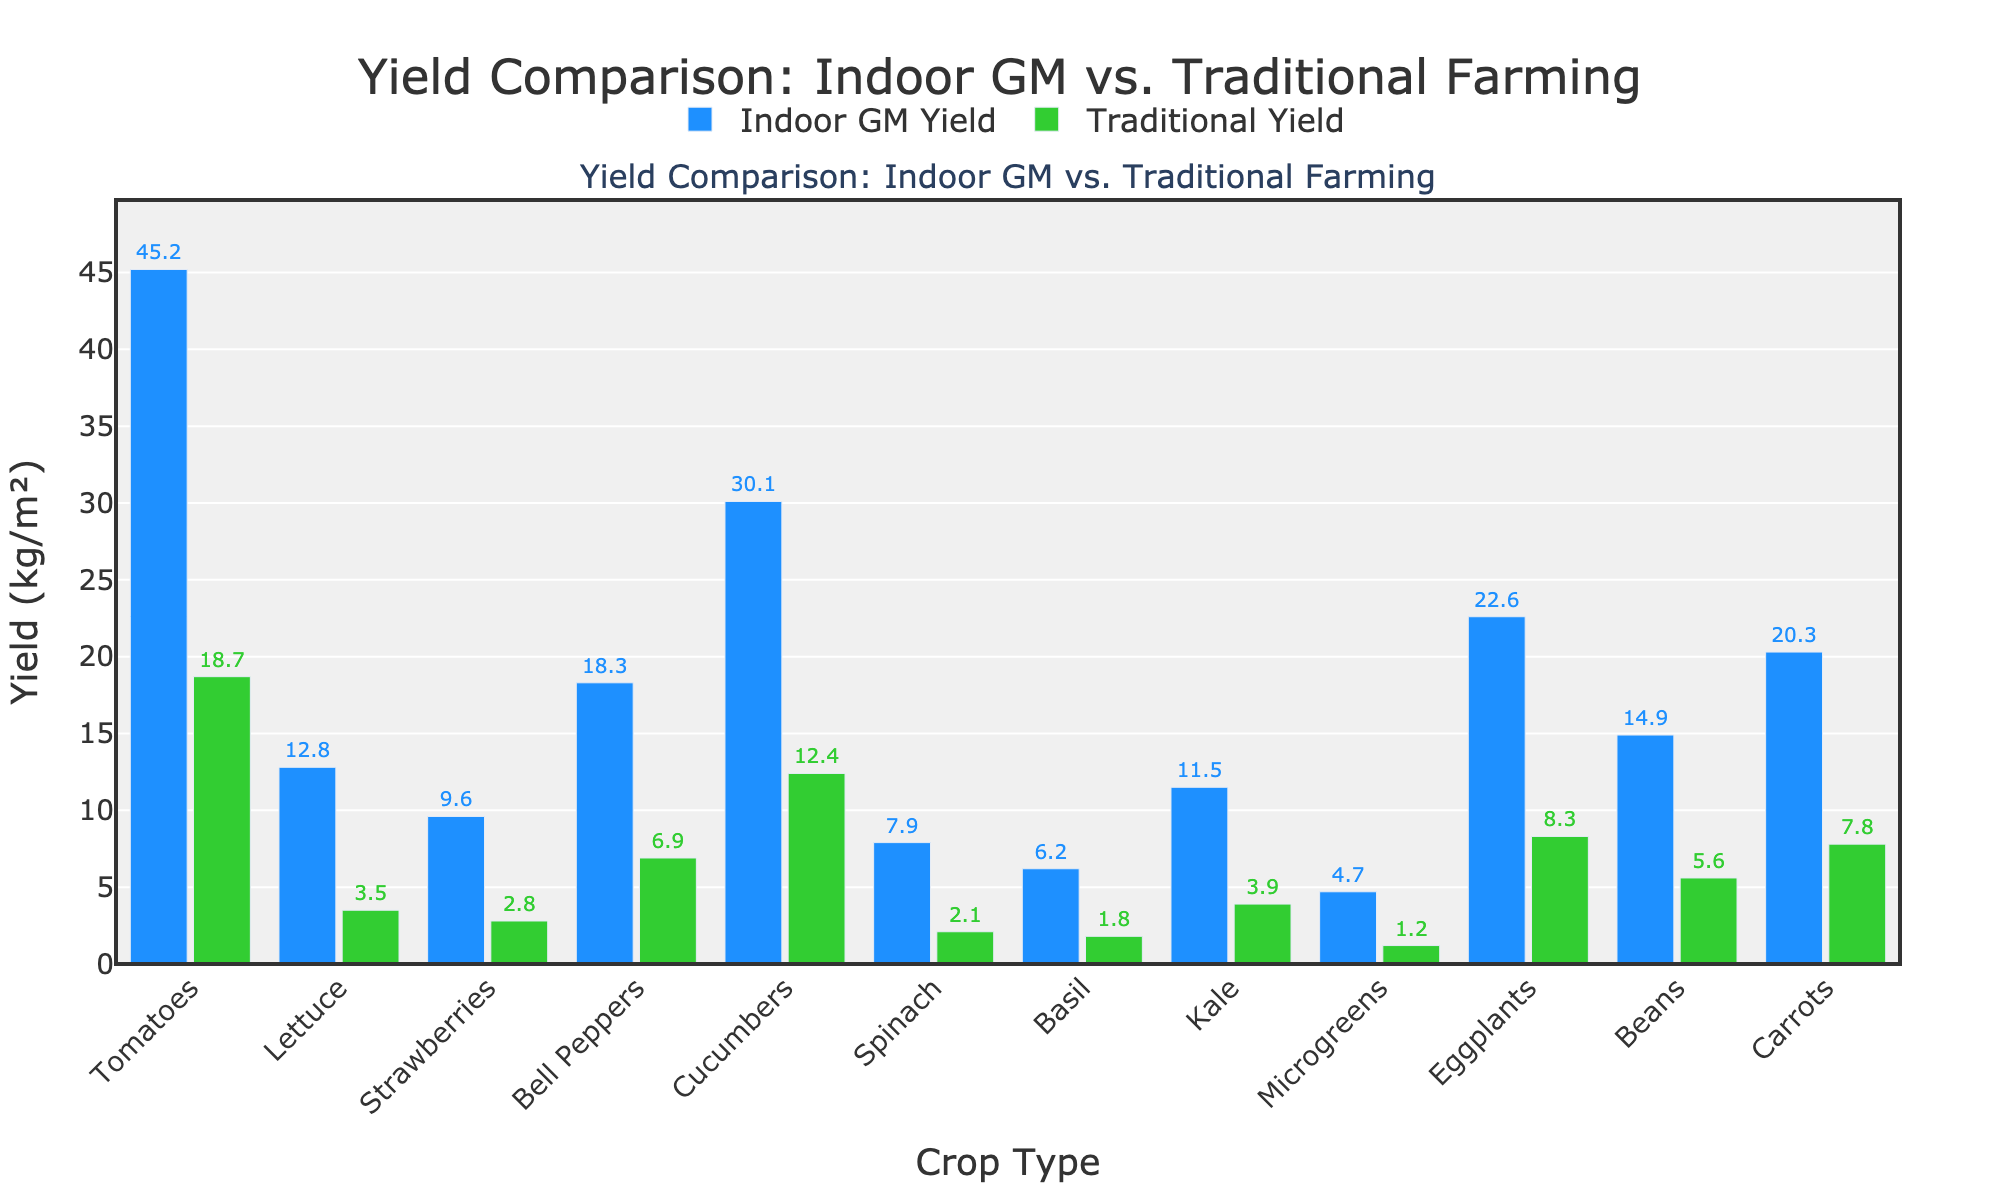What crop shows the highest yield difference between Indoor GM and Traditional methods? To find the crop with the highest yield difference, subtract the traditional yield from the Indoor GM yield for each crop. The differences are: Tomatoes (26.5), Lettuce (9.3), Strawberries (6.8), Bell Peppers (11.4), Cucumbers (17.7), Spinach (5.8), Basil (4.4), Kale (7.6), Microgreens (3.5), Eggplants (14.3), Beans (9.3), Carrots (12.5). Tomatoes have the highest yield difference of 26.5.
Answer: Tomatoes Which crop has the smallest yield difference between Indoor GM and Traditional methods? Subtract the traditional yield from the Indoor GM yield for each crop: Tomatoes (26.5), Lettuce (9.3), Strawberries (6.8), Bell Peppers (11.4), Cucumbers (17.7), Spinach (5.8), Basil (4.4), Kale (7.6), Microgreens (3.5), Eggplants (14.3), Beans (9.3), Carrots (12.5). Microgreens have the smallest yield difference of 3.5.
Answer: Microgreens Which crops have a traditional yield greater than 5 kg/m²? From the bar chart, the crops with a traditional yield greater than 5 kg/m² are Beans (5.6 kg/m²), Bell Peppers (6.9 kg/m²), Eggplants (8.3 kg/m²), Cucumbers (12.4 kg/m²), and Carrots (7.8 kg/m²).
Answer: Beans, Bell Peppers, Eggplants, Cucumbers, Carrots What is the average yield of cucumbers across both farming methods? Add the yields of cucumbers from both methods: Indoor GM (30.1 kg/m²) + Traditional (12.4 kg/m²) = 42.5 kg/m². The average is 42.5 kg/m² divided by 2, which is 21.25 kg/m².
Answer: 21.25 Which crop has the highest indoor GM yield and what is it? From the bar chart, the crop with the highest indoor GM yield is Tomatoes with a yield of 45.2 kg/m².
Answer: Tomatoes, 45.2 kg/m² What percentage of the indoor GM yield does the traditional yield of Lettuce represent? To find the percentage, divide the traditional yield (3.5 kg/m²) by the indoor GM yield (12.8 kg/m²) and multiply by 100: (3.5 / 12.8) * 100 = 27.34%.
Answer: 27.3% How much greater is the yield of Indoor GM Eggplants compared to Traditional Eggplants? Subtract the traditional yield of Eggplants (8.3 kg/m²) from the indoor GM yield (22.6 kg/m²): 22.6 - 8.3 = 14.3 kg/m².
Answer: 14.3 kg/m² Does the yield of Indoor GM Kale exceed that of traditional Tomatoes? Compare the yield of Indoor GM Kale (11.5 kg/m²) with the yield of traditional Tomatoes (18.7 kg/m²). 11.5 kg/m² is less than 18.7 kg/m².
Answer: No 